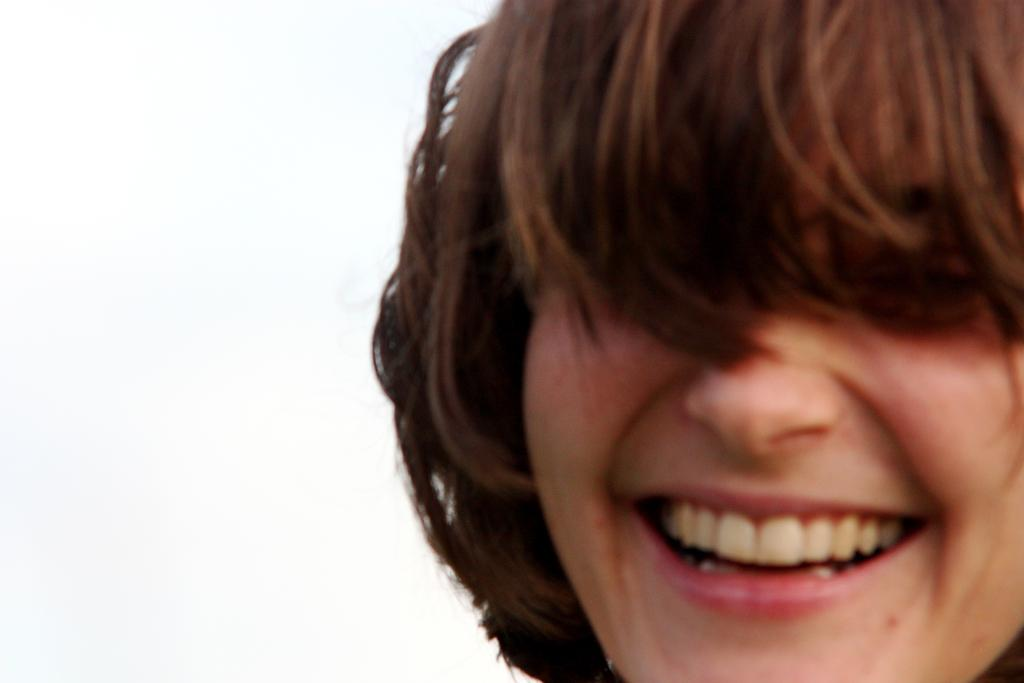What is present in the image? There is a person in the image. How is the person's facial expression? The person is smiling. What type of quartz can be seen in the person's hand in the image? There is no quartz present in the image; the person is simply smiling. What type of corn is being grown in the background of the image? There is no background or corn visible in the image, as it only features a person smiling. 